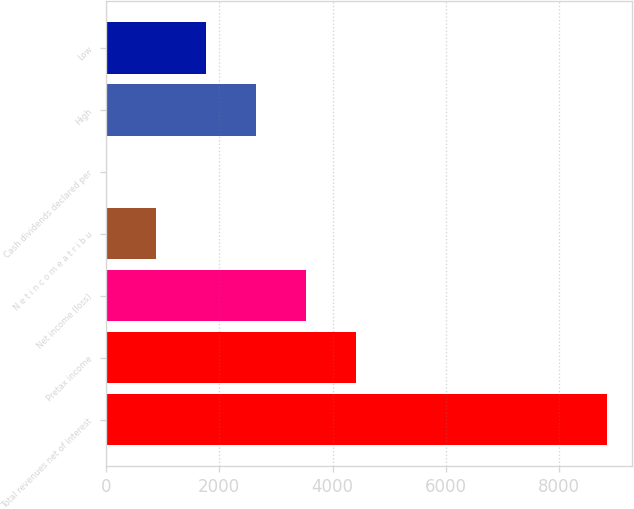Convert chart. <chart><loc_0><loc_0><loc_500><loc_500><bar_chart><fcel>Total revenues net of interest<fcel>Pretax income<fcel>Net income (loss)<fcel>N e t i n c o m e a t r i b u<fcel>Cash dividends declared per<fcel>High<fcel>Low<nl><fcel>8839<fcel>4419.68<fcel>3535.81<fcel>884.22<fcel>0.35<fcel>2651.95<fcel>1768.09<nl></chart> 